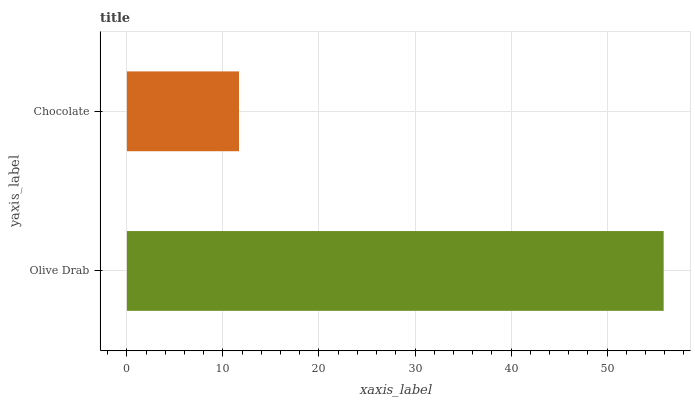Is Chocolate the minimum?
Answer yes or no. Yes. Is Olive Drab the maximum?
Answer yes or no. Yes. Is Chocolate the maximum?
Answer yes or no. No. Is Olive Drab greater than Chocolate?
Answer yes or no. Yes. Is Chocolate less than Olive Drab?
Answer yes or no. Yes. Is Chocolate greater than Olive Drab?
Answer yes or no. No. Is Olive Drab less than Chocolate?
Answer yes or no. No. Is Olive Drab the high median?
Answer yes or no. Yes. Is Chocolate the low median?
Answer yes or no. Yes. Is Chocolate the high median?
Answer yes or no. No. Is Olive Drab the low median?
Answer yes or no. No. 